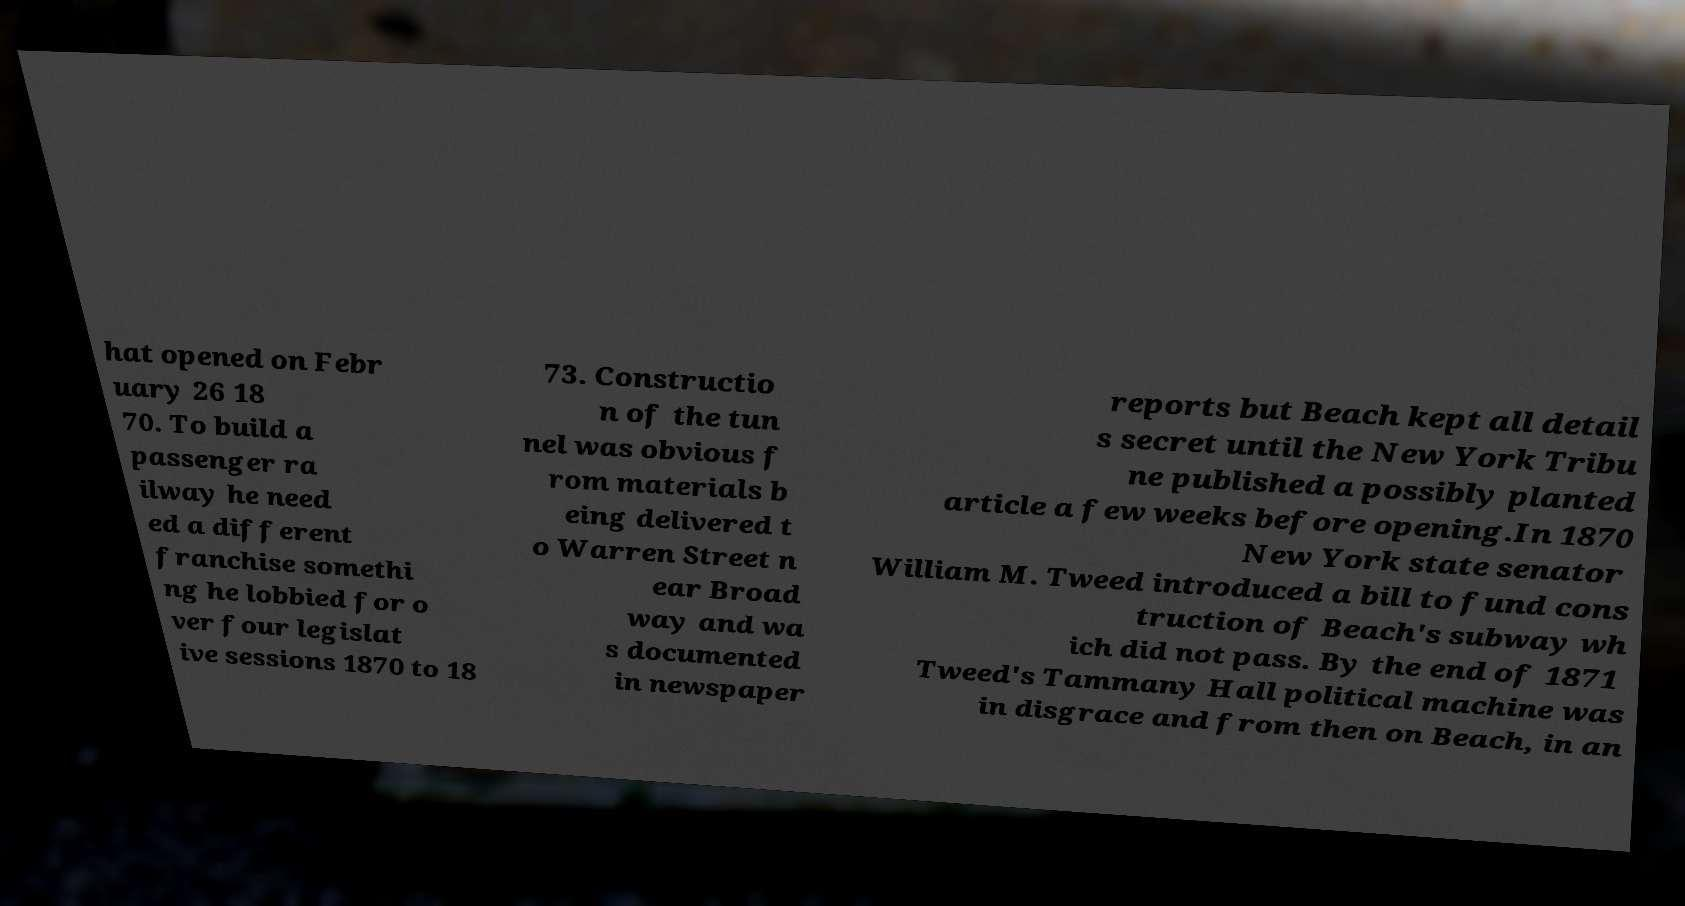Please identify and transcribe the text found in this image. hat opened on Febr uary 26 18 70. To build a passenger ra ilway he need ed a different franchise somethi ng he lobbied for o ver four legislat ive sessions 1870 to 18 73. Constructio n of the tun nel was obvious f rom materials b eing delivered t o Warren Street n ear Broad way and wa s documented in newspaper reports but Beach kept all detail s secret until the New York Tribu ne published a possibly planted article a few weeks before opening.In 1870 New York state senator William M. Tweed introduced a bill to fund cons truction of Beach's subway wh ich did not pass. By the end of 1871 Tweed's Tammany Hall political machine was in disgrace and from then on Beach, in an 